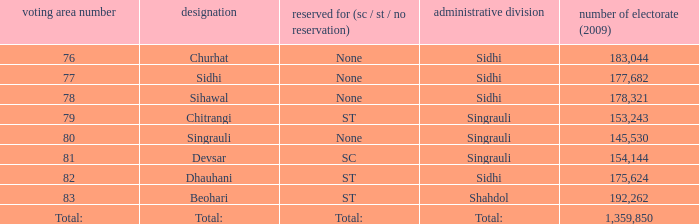What is the district with 79 constituency number? Singrauli. Would you be able to parse every entry in this table? {'header': ['voting area number', 'designation', 'reserved for (sc / st / no reservation)', 'administrative division', 'number of electorate (2009)'], 'rows': [['76', 'Churhat', 'None', 'Sidhi', '183,044'], ['77', 'Sidhi', 'None', 'Sidhi', '177,682'], ['78', 'Sihawal', 'None', 'Sidhi', '178,321'], ['79', 'Chitrangi', 'ST', 'Singrauli', '153,243'], ['80', 'Singrauli', 'None', 'Singrauli', '145,530'], ['81', 'Devsar', 'SC', 'Singrauli', '154,144'], ['82', 'Dhauhani', 'ST', 'Sidhi', '175,624'], ['83', 'Beohari', 'ST', 'Shahdol', '192,262'], ['Total:', 'Total:', 'Total:', 'Total:', '1,359,850']]} 